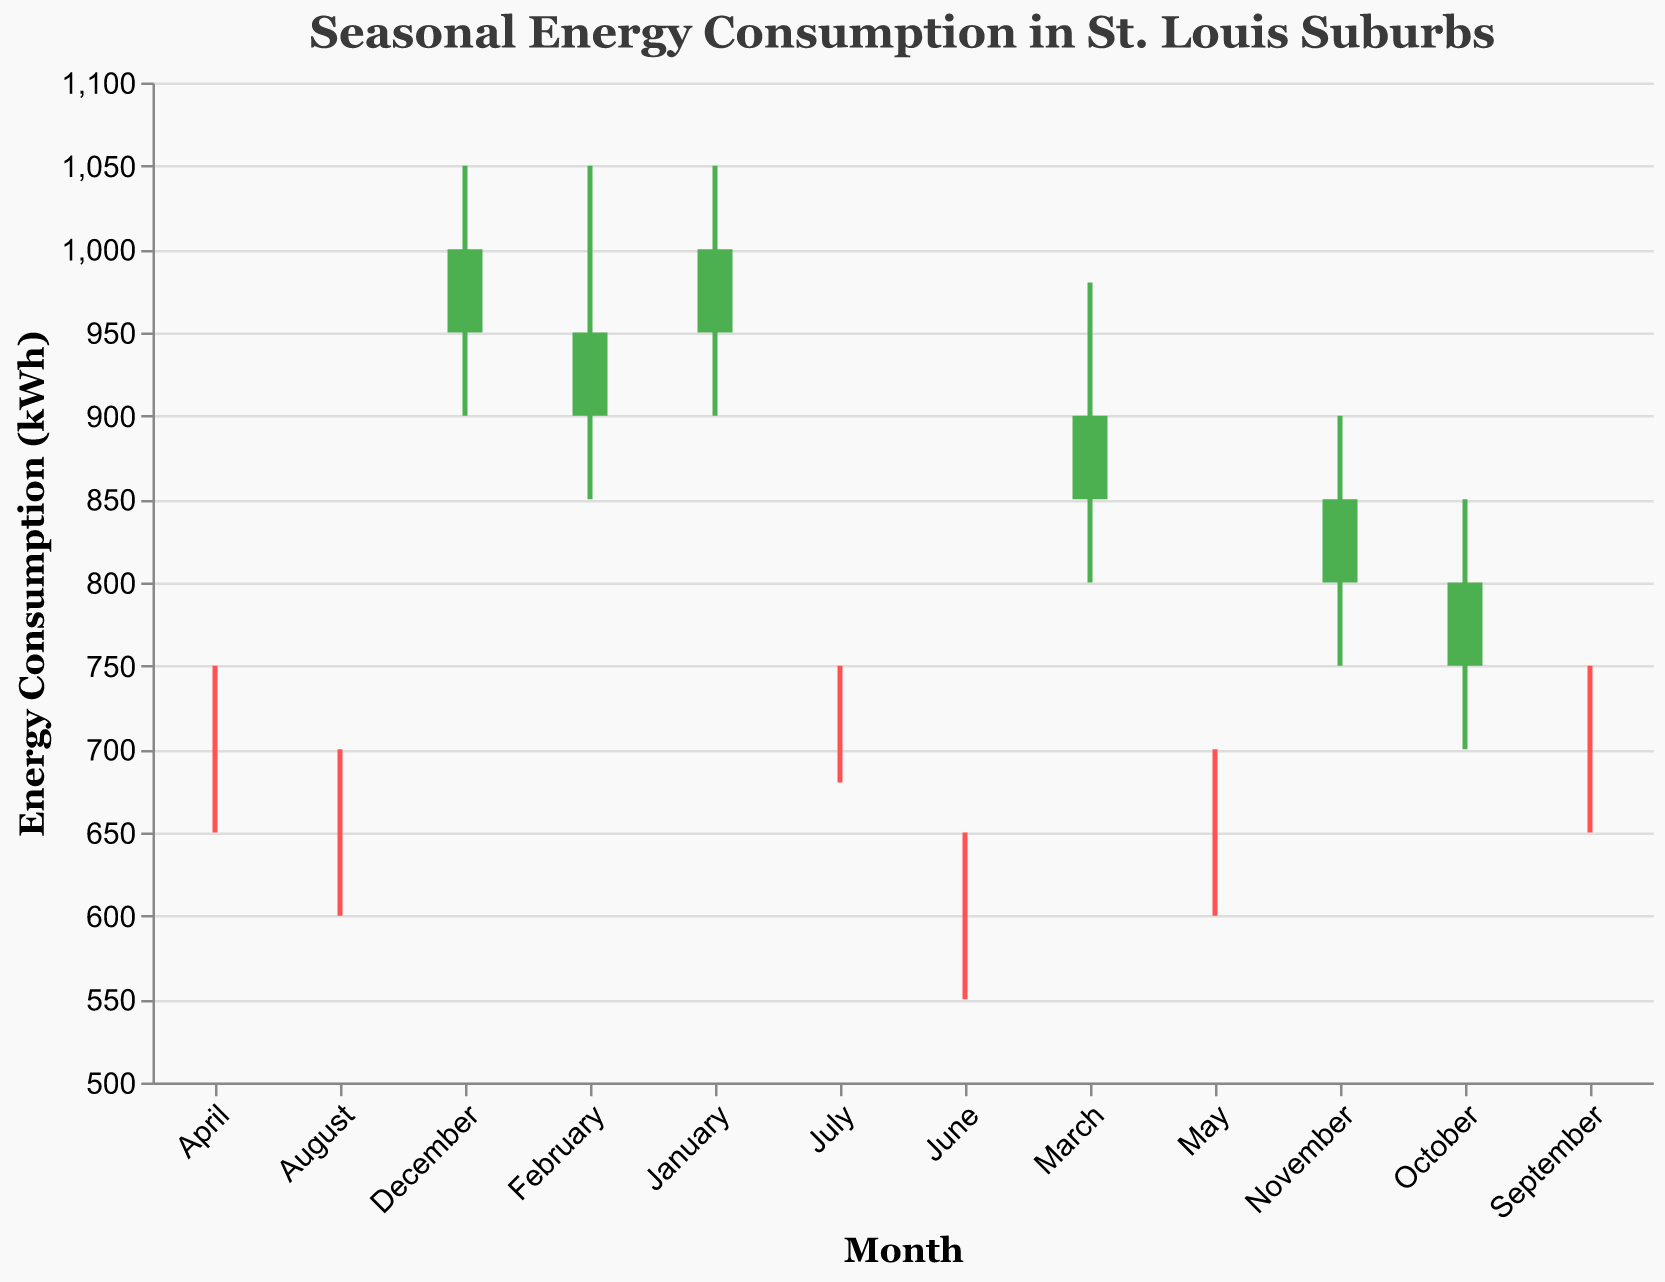What is the highest energy consumption recorded in January? The high value for January is labeled as 1050 on the y-axis in the figure.
Answer: 1050 Which month has the lowest 'Open' energy consumption value and what is it? Compare the 'Open' values for each month; June's 'Open' value is the lowest at 600.
Answer: June, 600 What is the difference between the high and low energy consumption in November? November's high value is 900 and the low value is 750. The difference is 900 - 750 = 150.
Answer: 150 From the figure, which months show increasing energy consumption from their 'Open' to 'Close' values? The figure uses color to signify increases in 'Close' over 'Open' values. The green-colored months are January, July, September, October, and December.
Answer: January, July, September, October, December How does the energy consumption in March compare to that in April? The 'Close' values for March and April are 900 and 700, respectively. March's 'Close' value is higher than April's.
Answer: March has higher energy consumption Calculate the average 'Close' value across all the months. Add up all the 'Close' values and divide by the number of months: (1000 + 950 + 900 + 700 + 650 + 600 + 700 + 650 + 700 + 800 + 850 + 1000)/12 = 850.
Answer: 850 Which month has the largest range (difference between high and low)? For each month, subtract the 'Low' from the 'High'. January, February, and December have the same range of 150, which is the highest.
Answer: January, February, December What is the trend in energy consumption from June to September? The 'Close' values for June, July, August, and September are 600, 700, 650, and 700 respectively. After an increase in July, there is a dip in August, followed by another increase in September, signaling a fluctuating uptrend.
Answer: Fluctuating uptrend Identify any months where the 'High' and 'Low' values are the same. There are no months where the 'High' and 'Low' values are the same based on the provided data from the figure.
Answer: None 